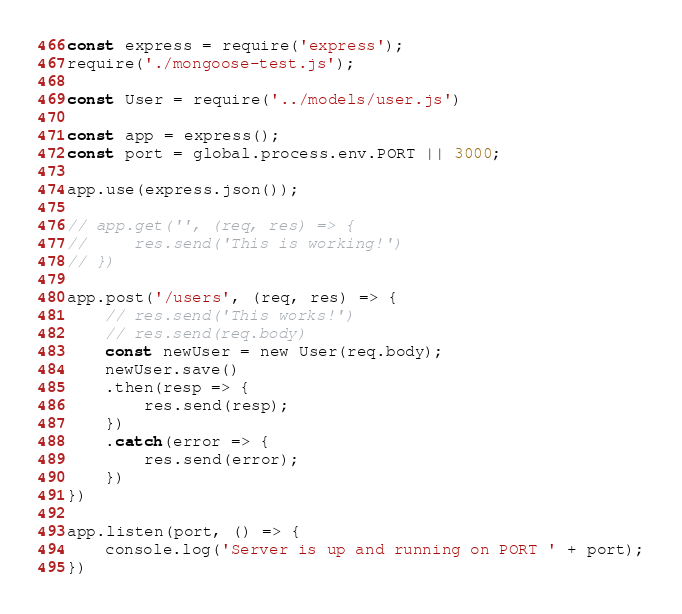Convert code to text. <code><loc_0><loc_0><loc_500><loc_500><_JavaScript_>const express = require('express');
require('./mongoose-test.js');

const User = require('../models/user.js')

const app = express();
const port = global.process.env.PORT || 3000;

app.use(express.json());

// app.get('', (req, res) => {
//     res.send('This is working!')
// })

app.post('/users', (req, res) => {
    // res.send('This works!')
    // res.send(req.body)
    const newUser = new User(req.body);
    newUser.save()
    .then(resp => {
        res.send(resp);
    })
    .catch(error => {
        res.send(error);
    })
})

app.listen(port, () => {
    console.log('Server is up and running on PORT ' + port);
})</code> 